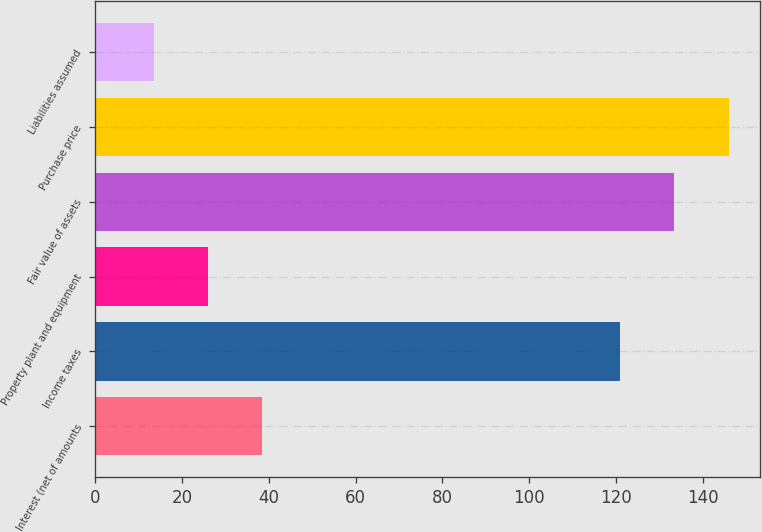<chart> <loc_0><loc_0><loc_500><loc_500><bar_chart><fcel>Interest (net of amounts<fcel>Income taxes<fcel>Property plant and equipment<fcel>Fair value of assets<fcel>Purchase price<fcel>Liabilities assumed<nl><fcel>38.43<fcel>120.9<fcel>25.92<fcel>133.41<fcel>145.92<fcel>13.41<nl></chart> 